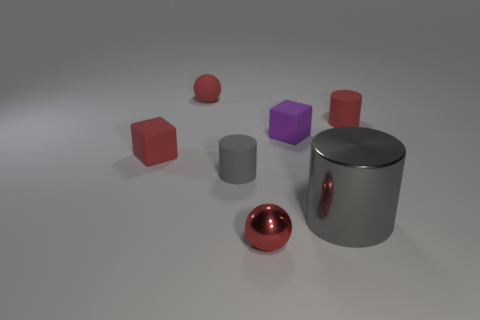What size is the red rubber thing that is the same shape as the gray rubber object?
Provide a succinct answer. Small. Is the number of small red cylinders that are to the right of the tiny red rubber cylinder less than the number of tiny gray cylinders that are in front of the small gray rubber cylinder?
Keep it short and to the point. No. What shape is the thing that is both left of the gray metal thing and in front of the gray rubber thing?
Keep it short and to the point. Sphere. What is the size of the ball that is made of the same material as the big gray cylinder?
Provide a short and direct response. Small. Does the shiny cylinder have the same color as the small cylinder right of the gray metallic cylinder?
Your response must be concise. No. What material is the thing that is both in front of the small gray cylinder and on the left side of the large thing?
Make the answer very short. Metal. What size is the matte cube that is the same color as the matte ball?
Keep it short and to the point. Small. There is a tiny rubber thing that is to the right of the small purple block; does it have the same shape as the tiny red matte thing that is in front of the small purple matte object?
Your answer should be compact. No. Is there a red metallic object?
Ensure brevity in your answer.  Yes. There is another tiny thing that is the same shape as the small gray rubber thing; what is its color?
Offer a terse response. Red. 